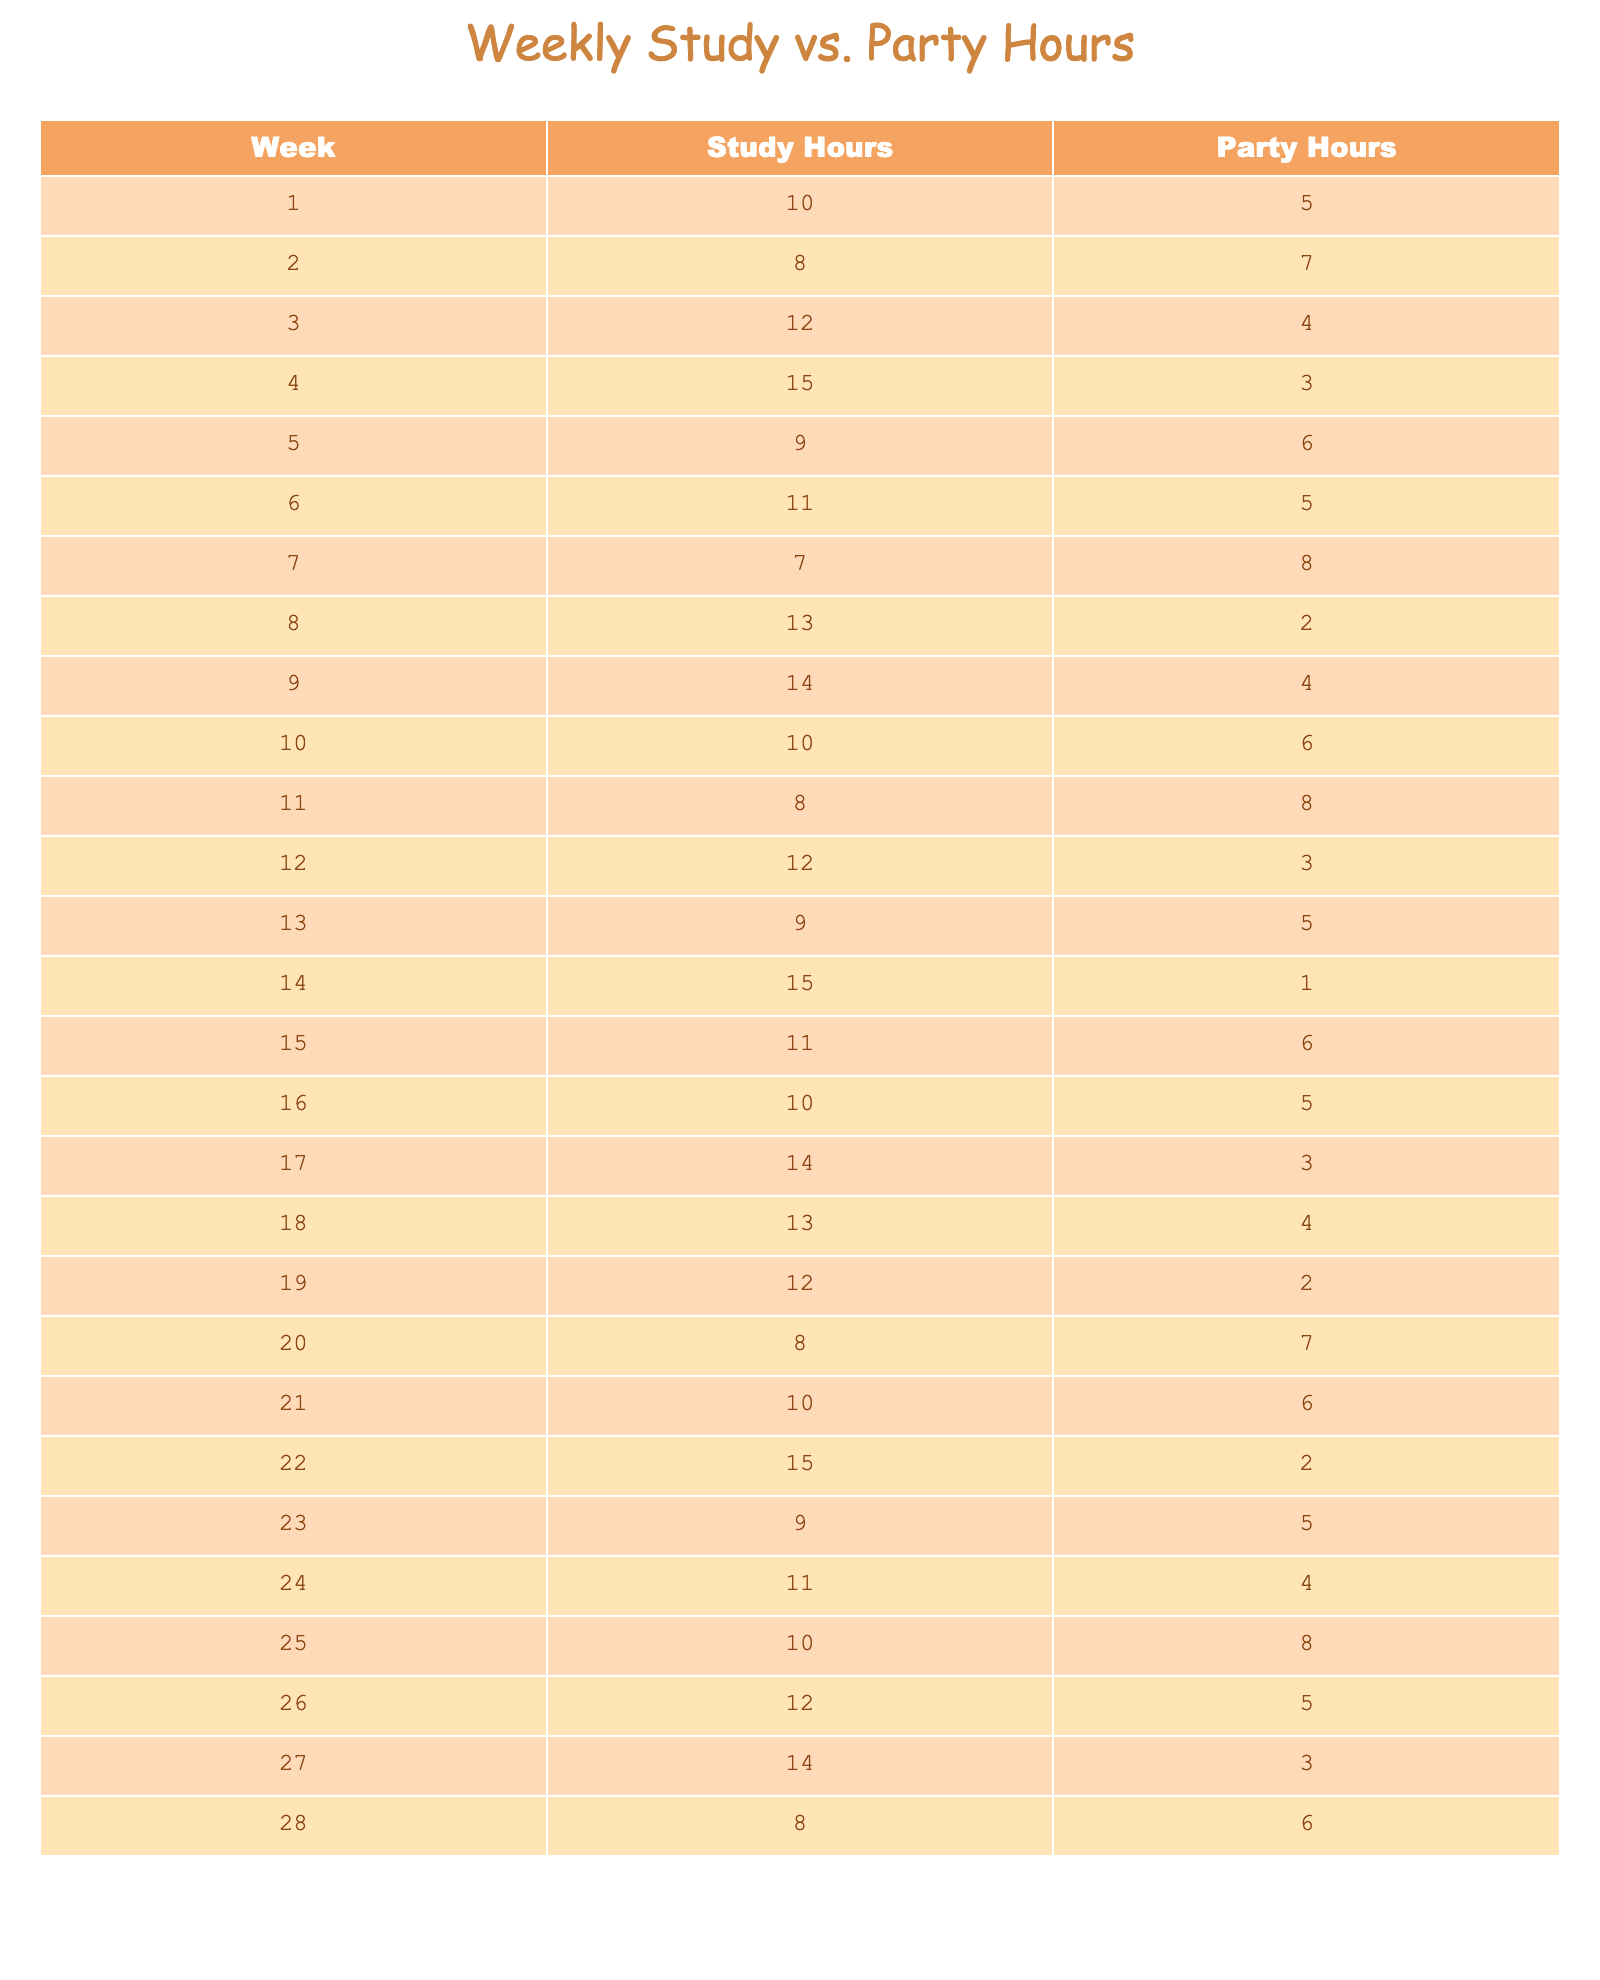What was the total study hours in Week 1? The table indicates that in Week 1, the study hours are specifically noted as 10.
Answer: 10 How many party hours were there in Week 5? According to the table, the party hours for Week 5 are recorded as 6.
Answer: 6 What is the average number of study hours over the 28 weeks? To find the average study hours, sum all the study hours: (10 + 8 + 12 + 15 + 9 + 11 + 7 + 13 + 14 + 10 + 8 + 12 + 9 + 15 + 11 + 10 + 14 + 13 + 12 + 8 + 10 + 15 + 9 + 11 + 10 + 12 + 14 + 8) =  as 290 and divide by 28, which results in an average of 10.36.
Answer: 10.36 Do any weeks have equal hours for study and party? By inspecting the column values, Weeks 11 and 7 show equal hours of 8 for study and party, thus confirming that there are weeks with equal hours.
Answer: Yes What is the percentage decrease in party hours from Week 1 to Week 4? In Week 1, there are 5 party hours, and in Week 4, there are 3 party hours. The decrease is 5 - 3 = 2 hours. To calculate the percentage decrease: (2 / 5) * 100 = 40%.
Answer: 40% In which week were the highest study hours recorded? By reviewing the table, Week 4 has the highest recorded study hours of 15.
Answer: Week 4 What is the total number of party hours over the 28-week period? To determine total party hours, sum all the party hours: (5 + 7 + 4 + 3 + 6 + 5 + 8 + 2 + 4 + 6 + 8 + 3 + 5 + 1 + 6 + 5 + 3 + 4 + 2 + 7 + 6 + 2 + 5 + 4 + 8 + 5 + 3 + 6) = 116 party hours total.
Answer: 116 Which week had the least amount of study hours? By reviewing the table, Week 7 has the least number of study hours recorded, which is 7.
Answer: Week 7 What were the study hours in the week before the highest party hours? The highest party hours were 8 in Week 7. The week before that is Week 6, which has study hours of 11.
Answer: 11 